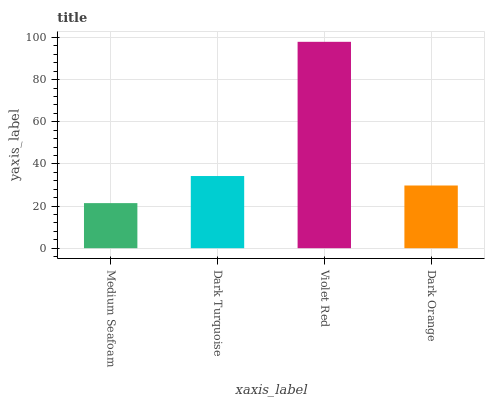Is Dark Turquoise the minimum?
Answer yes or no. No. Is Dark Turquoise the maximum?
Answer yes or no. No. Is Dark Turquoise greater than Medium Seafoam?
Answer yes or no. Yes. Is Medium Seafoam less than Dark Turquoise?
Answer yes or no. Yes. Is Medium Seafoam greater than Dark Turquoise?
Answer yes or no. No. Is Dark Turquoise less than Medium Seafoam?
Answer yes or no. No. Is Dark Turquoise the high median?
Answer yes or no. Yes. Is Dark Orange the low median?
Answer yes or no. Yes. Is Medium Seafoam the high median?
Answer yes or no. No. Is Dark Turquoise the low median?
Answer yes or no. No. 